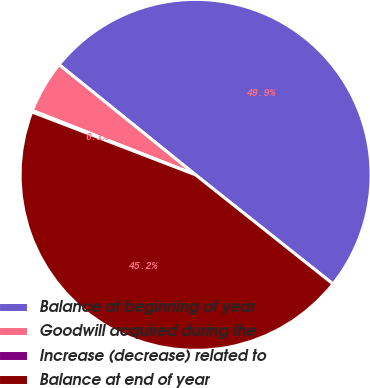Convert chart. <chart><loc_0><loc_0><loc_500><loc_500><pie_chart><fcel>Balance at beginning of year<fcel>Goodwill acquired during the<fcel>Increase (decrease) related to<fcel>Balance at end of year<nl><fcel>49.87%<fcel>4.84%<fcel>0.13%<fcel>45.16%<nl></chart> 